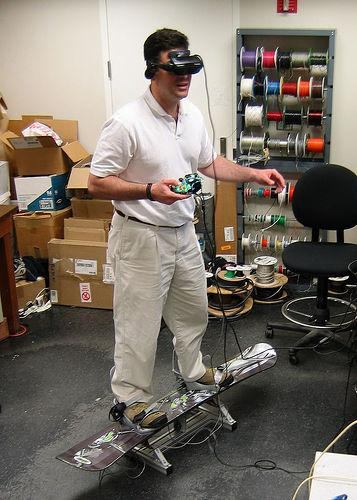Provide a brief description of the primary focus in the image. A man is standing on a skateboard and playing a virtual reality snowboarding game with a hand-held controller. How is the man in the image interacting with the virtual reality device? The man interacts with the VR device by wearing face gear, standing on a skateboard, and holding a game controller. Write a concise overview of the main activity happening in the image. Man in white shirt, with face gear, is playing a virtual reality game while standing on a skateboard. What is the man in the image participating in? The man is engaged in a virtual reality snowboarding game, standing on a skateboard with a controller in his hand. Mention the significant objects involved in the man's activity. The man's activity involves a skateboard, a face gear, a hand-held controller, and a virtual reality snowboarding game. Mention the key elements in the scene and the man's outfit. Man wearing a short-sleeved white shirt, pants and face gear, stands on a skateboard while holding a green controller. Write a brief summary of the image, focusing on the man and his actions. A man in a white shirt is immersed in a VR snowboarding game, using face gear and standing on a skateboard with a controller. Explain what the man is doing and the objects involved in the activity. The man is playing a virtual reality snowboarding game, using a face gear, a skateboard, and a hand-held controller. Enumerate the key elements observed in the image, including the man and his activity. Man, skateboard, virtual reality game, face gear, hand-held controller, white shirt, and pants. Describe the man's appearance and the action he is performing. A man with thick dark long hair, wearing a white shirt, is immersed in a virtual reality game while standing on a skateboard. 